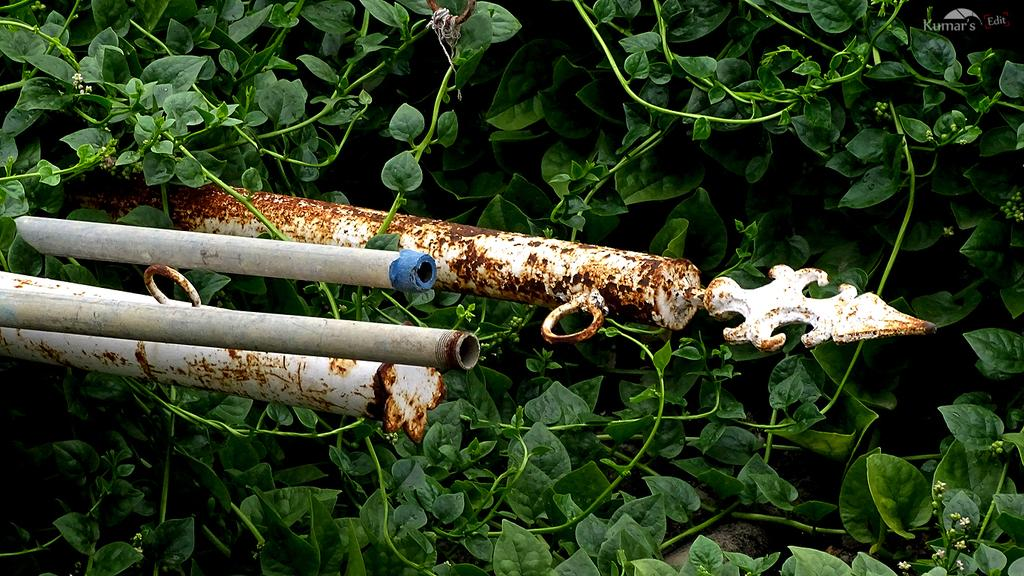What is the main object in the center of the image? There is a rod in the center of the image. What can be seen in the background of the image? There are plants in the background of the image. What type of noise can be heard coming from the rod in the image? There is no noise coming from the rod in the image, as it is a static object. 